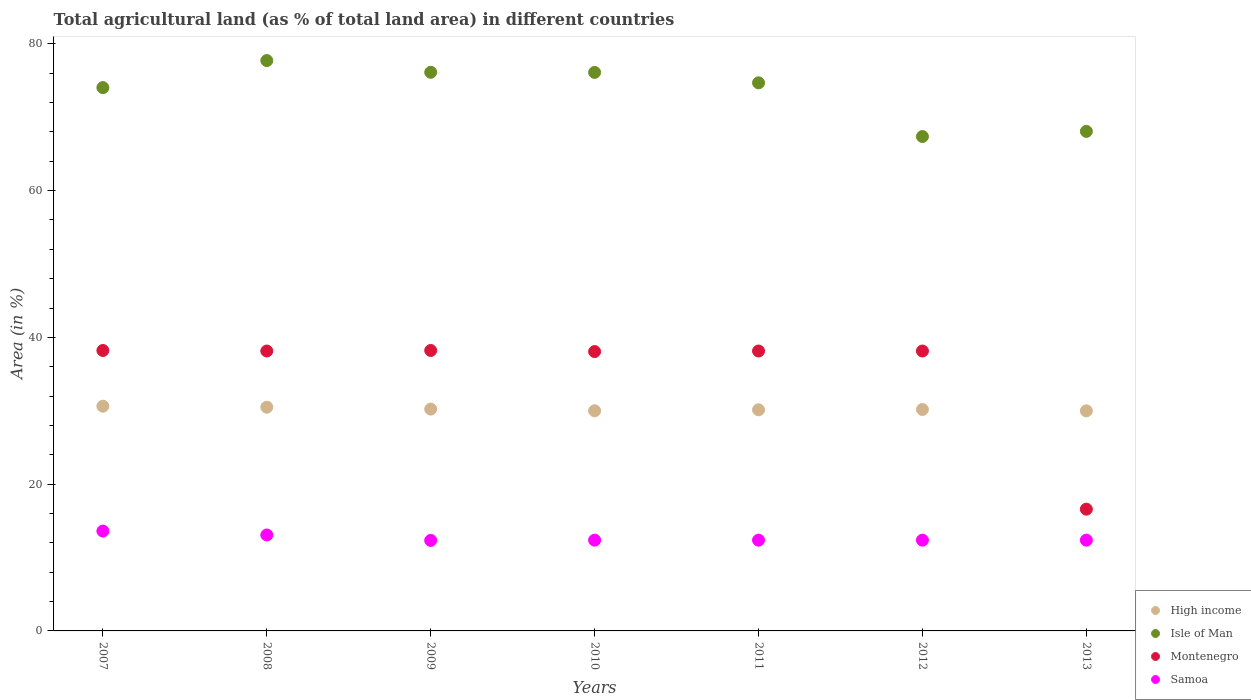Is the number of dotlines equal to the number of legend labels?
Your answer should be very brief. Yes. What is the percentage of agricultural land in Samoa in 2010?
Offer a terse response. 12.37. Across all years, what is the maximum percentage of agricultural land in Isle of Man?
Ensure brevity in your answer.  77.72. Across all years, what is the minimum percentage of agricultural land in Isle of Man?
Offer a terse response. 67.37. In which year was the percentage of agricultural land in Samoa maximum?
Keep it short and to the point. 2007. In which year was the percentage of agricultural land in Isle of Man minimum?
Your response must be concise. 2012. What is the total percentage of agricultural land in Isle of Man in the graph?
Keep it short and to the point. 514.11. What is the difference between the percentage of agricultural land in Isle of Man in 2010 and that in 2012?
Provide a succinct answer. 8.74. What is the difference between the percentage of agricultural land in High income in 2008 and the percentage of agricultural land in Samoa in 2012?
Provide a short and direct response. 18.12. What is the average percentage of agricultural land in Montenegro per year?
Give a very brief answer. 35.07. In the year 2007, what is the difference between the percentage of agricultural land in Isle of Man and percentage of agricultural land in High income?
Give a very brief answer. 43.41. In how many years, is the percentage of agricultural land in Samoa greater than 52 %?
Your answer should be very brief. 0. What is the ratio of the percentage of agricultural land in Samoa in 2008 to that in 2011?
Ensure brevity in your answer.  1.06. Is the difference between the percentage of agricultural land in Isle of Man in 2007 and 2013 greater than the difference between the percentage of agricultural land in High income in 2007 and 2013?
Give a very brief answer. Yes. What is the difference between the highest and the second highest percentage of agricultural land in Montenegro?
Your response must be concise. 0. What is the difference between the highest and the lowest percentage of agricultural land in Samoa?
Ensure brevity in your answer.  1.27. In how many years, is the percentage of agricultural land in Montenegro greater than the average percentage of agricultural land in Montenegro taken over all years?
Ensure brevity in your answer.  6. Is the sum of the percentage of agricultural land in Isle of Man in 2007 and 2012 greater than the maximum percentage of agricultural land in Montenegro across all years?
Your answer should be very brief. Yes. Is it the case that in every year, the sum of the percentage of agricultural land in Isle of Man and percentage of agricultural land in High income  is greater than the sum of percentage of agricultural land in Montenegro and percentage of agricultural land in Samoa?
Give a very brief answer. Yes. Is the percentage of agricultural land in Samoa strictly greater than the percentage of agricultural land in High income over the years?
Offer a very short reply. No. Are the values on the major ticks of Y-axis written in scientific E-notation?
Keep it short and to the point. No. Does the graph contain any zero values?
Offer a terse response. No. Does the graph contain grids?
Your response must be concise. No. Where does the legend appear in the graph?
Your answer should be very brief. Bottom right. What is the title of the graph?
Provide a succinct answer. Total agricultural land (as % of total land area) in different countries. Does "Portugal" appear as one of the legend labels in the graph?
Your answer should be very brief. No. What is the label or title of the Y-axis?
Your answer should be compact. Area (in %). What is the Area (in %) in High income in 2007?
Your response must be concise. 30.62. What is the Area (in %) of Isle of Man in 2007?
Make the answer very short. 74.04. What is the Area (in %) in Montenegro in 2007?
Give a very brief answer. 38.22. What is the Area (in %) of Samoa in 2007?
Your answer should be very brief. 13.6. What is the Area (in %) in High income in 2008?
Provide a short and direct response. 30.49. What is the Area (in %) of Isle of Man in 2008?
Make the answer very short. 77.72. What is the Area (in %) of Montenegro in 2008?
Your answer should be very brief. 38.14. What is the Area (in %) of Samoa in 2008?
Ensure brevity in your answer.  13.07. What is the Area (in %) in High income in 2009?
Make the answer very short. 30.23. What is the Area (in %) in Isle of Man in 2009?
Your response must be concise. 76.12. What is the Area (in %) of Montenegro in 2009?
Keep it short and to the point. 38.22. What is the Area (in %) in Samoa in 2009?
Keep it short and to the point. 12.33. What is the Area (in %) of High income in 2010?
Give a very brief answer. 30. What is the Area (in %) in Isle of Man in 2010?
Offer a terse response. 76.11. What is the Area (in %) of Montenegro in 2010?
Give a very brief answer. 38.07. What is the Area (in %) of Samoa in 2010?
Provide a succinct answer. 12.37. What is the Area (in %) in High income in 2011?
Provide a short and direct response. 30.13. What is the Area (in %) of Isle of Man in 2011?
Make the answer very short. 74.68. What is the Area (in %) of Montenegro in 2011?
Your response must be concise. 38.14. What is the Area (in %) in Samoa in 2011?
Offer a terse response. 12.37. What is the Area (in %) in High income in 2012?
Give a very brief answer. 30.17. What is the Area (in %) in Isle of Man in 2012?
Make the answer very short. 67.37. What is the Area (in %) of Montenegro in 2012?
Keep it short and to the point. 38.14. What is the Area (in %) of Samoa in 2012?
Provide a short and direct response. 12.37. What is the Area (in %) of High income in 2013?
Make the answer very short. 29.99. What is the Area (in %) in Isle of Man in 2013?
Make the answer very short. 68.07. What is the Area (in %) of Montenegro in 2013?
Keep it short and to the point. 16.59. What is the Area (in %) of Samoa in 2013?
Your response must be concise. 12.37. Across all years, what is the maximum Area (in %) of High income?
Your answer should be very brief. 30.62. Across all years, what is the maximum Area (in %) of Isle of Man?
Ensure brevity in your answer.  77.72. Across all years, what is the maximum Area (in %) in Montenegro?
Ensure brevity in your answer.  38.22. Across all years, what is the maximum Area (in %) in Samoa?
Offer a terse response. 13.6. Across all years, what is the minimum Area (in %) of High income?
Provide a short and direct response. 29.99. Across all years, what is the minimum Area (in %) of Isle of Man?
Offer a very short reply. 67.37. Across all years, what is the minimum Area (in %) in Montenegro?
Keep it short and to the point. 16.59. Across all years, what is the minimum Area (in %) of Samoa?
Offer a terse response. 12.33. What is the total Area (in %) in High income in the graph?
Provide a succinct answer. 211.62. What is the total Area (in %) of Isle of Man in the graph?
Offer a terse response. 514.11. What is the total Area (in %) of Montenegro in the graph?
Keep it short and to the point. 245.51. What is the total Area (in %) in Samoa in the graph?
Make the answer very short. 88.48. What is the difference between the Area (in %) of High income in 2007 and that in 2008?
Offer a terse response. 0.13. What is the difference between the Area (in %) in Isle of Man in 2007 and that in 2008?
Offer a terse response. -3.68. What is the difference between the Area (in %) in Montenegro in 2007 and that in 2008?
Your answer should be very brief. 0.07. What is the difference between the Area (in %) in Samoa in 2007 and that in 2008?
Keep it short and to the point. 0.53. What is the difference between the Area (in %) of High income in 2007 and that in 2009?
Keep it short and to the point. 0.39. What is the difference between the Area (in %) in Isle of Man in 2007 and that in 2009?
Keep it short and to the point. -2.09. What is the difference between the Area (in %) of Samoa in 2007 and that in 2009?
Give a very brief answer. 1.27. What is the difference between the Area (in %) of High income in 2007 and that in 2010?
Your answer should be compact. 0.62. What is the difference between the Area (in %) of Isle of Man in 2007 and that in 2010?
Ensure brevity in your answer.  -2.07. What is the difference between the Area (in %) in Montenegro in 2007 and that in 2010?
Your answer should be compact. 0.15. What is the difference between the Area (in %) in Samoa in 2007 and that in 2010?
Your response must be concise. 1.24. What is the difference between the Area (in %) in High income in 2007 and that in 2011?
Make the answer very short. 0.49. What is the difference between the Area (in %) of Isle of Man in 2007 and that in 2011?
Give a very brief answer. -0.65. What is the difference between the Area (in %) in Montenegro in 2007 and that in 2011?
Offer a very short reply. 0.07. What is the difference between the Area (in %) in Samoa in 2007 and that in 2011?
Make the answer very short. 1.24. What is the difference between the Area (in %) of High income in 2007 and that in 2012?
Keep it short and to the point. 0.45. What is the difference between the Area (in %) in Isle of Man in 2007 and that in 2012?
Offer a very short reply. 6.67. What is the difference between the Area (in %) in Montenegro in 2007 and that in 2012?
Offer a terse response. 0.07. What is the difference between the Area (in %) of Samoa in 2007 and that in 2012?
Make the answer very short. 1.24. What is the difference between the Area (in %) of High income in 2007 and that in 2013?
Provide a succinct answer. 0.63. What is the difference between the Area (in %) of Isle of Man in 2007 and that in 2013?
Your answer should be compact. 5.96. What is the difference between the Area (in %) of Montenegro in 2007 and that in 2013?
Make the answer very short. 21.63. What is the difference between the Area (in %) in Samoa in 2007 and that in 2013?
Your answer should be compact. 1.24. What is the difference between the Area (in %) in High income in 2008 and that in 2009?
Your answer should be compact. 0.26. What is the difference between the Area (in %) of Isle of Man in 2008 and that in 2009?
Your answer should be compact. 1.6. What is the difference between the Area (in %) of Montenegro in 2008 and that in 2009?
Ensure brevity in your answer.  -0.07. What is the difference between the Area (in %) of Samoa in 2008 and that in 2009?
Make the answer very short. 0.74. What is the difference between the Area (in %) in High income in 2008 and that in 2010?
Your answer should be very brief. 0.49. What is the difference between the Area (in %) of Isle of Man in 2008 and that in 2010?
Make the answer very short. 1.61. What is the difference between the Area (in %) in Montenegro in 2008 and that in 2010?
Your answer should be compact. 0.07. What is the difference between the Area (in %) of Samoa in 2008 and that in 2010?
Offer a terse response. 0.71. What is the difference between the Area (in %) in High income in 2008 and that in 2011?
Provide a succinct answer. 0.35. What is the difference between the Area (in %) in Isle of Man in 2008 and that in 2011?
Your answer should be compact. 3.04. What is the difference between the Area (in %) of Samoa in 2008 and that in 2011?
Your response must be concise. 0.71. What is the difference between the Area (in %) of High income in 2008 and that in 2012?
Your answer should be very brief. 0.31. What is the difference between the Area (in %) in Isle of Man in 2008 and that in 2012?
Provide a succinct answer. 10.35. What is the difference between the Area (in %) of Samoa in 2008 and that in 2012?
Your answer should be very brief. 0.71. What is the difference between the Area (in %) of High income in 2008 and that in 2013?
Your answer should be compact. 0.5. What is the difference between the Area (in %) in Isle of Man in 2008 and that in 2013?
Your response must be concise. 9.65. What is the difference between the Area (in %) of Montenegro in 2008 and that in 2013?
Keep it short and to the point. 21.55. What is the difference between the Area (in %) in Samoa in 2008 and that in 2013?
Your response must be concise. 0.71. What is the difference between the Area (in %) in High income in 2009 and that in 2010?
Keep it short and to the point. 0.23. What is the difference between the Area (in %) in Isle of Man in 2009 and that in 2010?
Provide a succinct answer. 0.02. What is the difference between the Area (in %) of Montenegro in 2009 and that in 2010?
Offer a terse response. 0.15. What is the difference between the Area (in %) of Samoa in 2009 and that in 2010?
Offer a terse response. -0.04. What is the difference between the Area (in %) of High income in 2009 and that in 2011?
Offer a very short reply. 0.1. What is the difference between the Area (in %) in Isle of Man in 2009 and that in 2011?
Give a very brief answer. 1.44. What is the difference between the Area (in %) of Montenegro in 2009 and that in 2011?
Your answer should be compact. 0.07. What is the difference between the Area (in %) of Samoa in 2009 and that in 2011?
Provide a succinct answer. -0.04. What is the difference between the Area (in %) of High income in 2009 and that in 2012?
Make the answer very short. 0.06. What is the difference between the Area (in %) of Isle of Man in 2009 and that in 2012?
Your response must be concise. 8.75. What is the difference between the Area (in %) in Montenegro in 2009 and that in 2012?
Make the answer very short. 0.07. What is the difference between the Area (in %) of Samoa in 2009 and that in 2012?
Give a very brief answer. -0.04. What is the difference between the Area (in %) of High income in 2009 and that in 2013?
Your answer should be compact. 0.24. What is the difference between the Area (in %) in Isle of Man in 2009 and that in 2013?
Offer a terse response. 8.05. What is the difference between the Area (in %) of Montenegro in 2009 and that in 2013?
Offer a very short reply. 21.63. What is the difference between the Area (in %) of Samoa in 2009 and that in 2013?
Offer a terse response. -0.04. What is the difference between the Area (in %) of High income in 2010 and that in 2011?
Give a very brief answer. -0.13. What is the difference between the Area (in %) of Isle of Man in 2010 and that in 2011?
Offer a terse response. 1.42. What is the difference between the Area (in %) of Montenegro in 2010 and that in 2011?
Your answer should be compact. -0.07. What is the difference between the Area (in %) in Samoa in 2010 and that in 2011?
Offer a very short reply. 0. What is the difference between the Area (in %) of High income in 2010 and that in 2012?
Offer a terse response. -0.17. What is the difference between the Area (in %) of Isle of Man in 2010 and that in 2012?
Offer a very short reply. 8.74. What is the difference between the Area (in %) in Montenegro in 2010 and that in 2012?
Provide a short and direct response. -0.07. What is the difference between the Area (in %) of High income in 2010 and that in 2013?
Offer a very short reply. 0.01. What is the difference between the Area (in %) in Isle of Man in 2010 and that in 2013?
Your response must be concise. 8.04. What is the difference between the Area (in %) of Montenegro in 2010 and that in 2013?
Ensure brevity in your answer.  21.48. What is the difference between the Area (in %) of Samoa in 2010 and that in 2013?
Your response must be concise. 0. What is the difference between the Area (in %) in High income in 2011 and that in 2012?
Ensure brevity in your answer.  -0.04. What is the difference between the Area (in %) in Isle of Man in 2011 and that in 2012?
Your answer should be compact. 7.32. What is the difference between the Area (in %) of Montenegro in 2011 and that in 2012?
Your answer should be very brief. 0. What is the difference between the Area (in %) of Samoa in 2011 and that in 2012?
Give a very brief answer. 0. What is the difference between the Area (in %) in High income in 2011 and that in 2013?
Ensure brevity in your answer.  0.14. What is the difference between the Area (in %) in Isle of Man in 2011 and that in 2013?
Your response must be concise. 6.61. What is the difference between the Area (in %) in Montenegro in 2011 and that in 2013?
Your answer should be very brief. 21.55. What is the difference between the Area (in %) in Samoa in 2011 and that in 2013?
Make the answer very short. 0. What is the difference between the Area (in %) of High income in 2012 and that in 2013?
Your response must be concise. 0.18. What is the difference between the Area (in %) in Isle of Man in 2012 and that in 2013?
Ensure brevity in your answer.  -0.7. What is the difference between the Area (in %) of Montenegro in 2012 and that in 2013?
Offer a terse response. 21.55. What is the difference between the Area (in %) in Samoa in 2012 and that in 2013?
Make the answer very short. 0. What is the difference between the Area (in %) in High income in 2007 and the Area (in %) in Isle of Man in 2008?
Give a very brief answer. -47.1. What is the difference between the Area (in %) in High income in 2007 and the Area (in %) in Montenegro in 2008?
Provide a short and direct response. -7.52. What is the difference between the Area (in %) in High income in 2007 and the Area (in %) in Samoa in 2008?
Offer a very short reply. 17.55. What is the difference between the Area (in %) of Isle of Man in 2007 and the Area (in %) of Montenegro in 2008?
Make the answer very short. 35.89. What is the difference between the Area (in %) in Isle of Man in 2007 and the Area (in %) in Samoa in 2008?
Offer a very short reply. 60.96. What is the difference between the Area (in %) of Montenegro in 2007 and the Area (in %) of Samoa in 2008?
Your answer should be compact. 25.14. What is the difference between the Area (in %) of High income in 2007 and the Area (in %) of Isle of Man in 2009?
Offer a very short reply. -45.5. What is the difference between the Area (in %) of High income in 2007 and the Area (in %) of Montenegro in 2009?
Your answer should be compact. -7.6. What is the difference between the Area (in %) in High income in 2007 and the Area (in %) in Samoa in 2009?
Offer a very short reply. 18.29. What is the difference between the Area (in %) in Isle of Man in 2007 and the Area (in %) in Montenegro in 2009?
Keep it short and to the point. 35.82. What is the difference between the Area (in %) of Isle of Man in 2007 and the Area (in %) of Samoa in 2009?
Keep it short and to the point. 61.7. What is the difference between the Area (in %) of Montenegro in 2007 and the Area (in %) of Samoa in 2009?
Your answer should be very brief. 25.88. What is the difference between the Area (in %) of High income in 2007 and the Area (in %) of Isle of Man in 2010?
Provide a succinct answer. -45.48. What is the difference between the Area (in %) of High income in 2007 and the Area (in %) of Montenegro in 2010?
Your answer should be very brief. -7.45. What is the difference between the Area (in %) of High income in 2007 and the Area (in %) of Samoa in 2010?
Provide a short and direct response. 18.25. What is the difference between the Area (in %) of Isle of Man in 2007 and the Area (in %) of Montenegro in 2010?
Offer a very short reply. 35.97. What is the difference between the Area (in %) in Isle of Man in 2007 and the Area (in %) in Samoa in 2010?
Ensure brevity in your answer.  61.67. What is the difference between the Area (in %) of Montenegro in 2007 and the Area (in %) of Samoa in 2010?
Your answer should be very brief. 25.85. What is the difference between the Area (in %) of High income in 2007 and the Area (in %) of Isle of Man in 2011?
Your response must be concise. -44.06. What is the difference between the Area (in %) of High income in 2007 and the Area (in %) of Montenegro in 2011?
Offer a very short reply. -7.52. What is the difference between the Area (in %) in High income in 2007 and the Area (in %) in Samoa in 2011?
Offer a very short reply. 18.25. What is the difference between the Area (in %) of Isle of Man in 2007 and the Area (in %) of Montenegro in 2011?
Your response must be concise. 35.89. What is the difference between the Area (in %) of Isle of Man in 2007 and the Area (in %) of Samoa in 2011?
Your answer should be very brief. 61.67. What is the difference between the Area (in %) in Montenegro in 2007 and the Area (in %) in Samoa in 2011?
Give a very brief answer. 25.85. What is the difference between the Area (in %) of High income in 2007 and the Area (in %) of Isle of Man in 2012?
Provide a short and direct response. -36.75. What is the difference between the Area (in %) of High income in 2007 and the Area (in %) of Montenegro in 2012?
Provide a short and direct response. -7.52. What is the difference between the Area (in %) in High income in 2007 and the Area (in %) in Samoa in 2012?
Provide a short and direct response. 18.25. What is the difference between the Area (in %) in Isle of Man in 2007 and the Area (in %) in Montenegro in 2012?
Your answer should be very brief. 35.89. What is the difference between the Area (in %) of Isle of Man in 2007 and the Area (in %) of Samoa in 2012?
Give a very brief answer. 61.67. What is the difference between the Area (in %) of Montenegro in 2007 and the Area (in %) of Samoa in 2012?
Your answer should be very brief. 25.85. What is the difference between the Area (in %) in High income in 2007 and the Area (in %) in Isle of Man in 2013?
Provide a short and direct response. -37.45. What is the difference between the Area (in %) in High income in 2007 and the Area (in %) in Montenegro in 2013?
Ensure brevity in your answer.  14.03. What is the difference between the Area (in %) of High income in 2007 and the Area (in %) of Samoa in 2013?
Provide a succinct answer. 18.25. What is the difference between the Area (in %) of Isle of Man in 2007 and the Area (in %) of Montenegro in 2013?
Your answer should be compact. 57.45. What is the difference between the Area (in %) in Isle of Man in 2007 and the Area (in %) in Samoa in 2013?
Offer a terse response. 61.67. What is the difference between the Area (in %) in Montenegro in 2007 and the Area (in %) in Samoa in 2013?
Your answer should be very brief. 25.85. What is the difference between the Area (in %) of High income in 2008 and the Area (in %) of Isle of Man in 2009?
Your answer should be very brief. -45.64. What is the difference between the Area (in %) in High income in 2008 and the Area (in %) in Montenegro in 2009?
Offer a terse response. -7.73. What is the difference between the Area (in %) in High income in 2008 and the Area (in %) in Samoa in 2009?
Offer a very short reply. 18.15. What is the difference between the Area (in %) of Isle of Man in 2008 and the Area (in %) of Montenegro in 2009?
Ensure brevity in your answer.  39.5. What is the difference between the Area (in %) of Isle of Man in 2008 and the Area (in %) of Samoa in 2009?
Make the answer very short. 65.39. What is the difference between the Area (in %) in Montenegro in 2008 and the Area (in %) in Samoa in 2009?
Ensure brevity in your answer.  25.81. What is the difference between the Area (in %) of High income in 2008 and the Area (in %) of Isle of Man in 2010?
Offer a very short reply. -45.62. What is the difference between the Area (in %) of High income in 2008 and the Area (in %) of Montenegro in 2010?
Keep it short and to the point. -7.58. What is the difference between the Area (in %) in High income in 2008 and the Area (in %) in Samoa in 2010?
Offer a terse response. 18.12. What is the difference between the Area (in %) of Isle of Man in 2008 and the Area (in %) of Montenegro in 2010?
Your answer should be compact. 39.65. What is the difference between the Area (in %) of Isle of Man in 2008 and the Area (in %) of Samoa in 2010?
Your answer should be very brief. 65.35. What is the difference between the Area (in %) in Montenegro in 2008 and the Area (in %) in Samoa in 2010?
Ensure brevity in your answer.  25.77. What is the difference between the Area (in %) in High income in 2008 and the Area (in %) in Isle of Man in 2011?
Provide a succinct answer. -44.2. What is the difference between the Area (in %) in High income in 2008 and the Area (in %) in Montenegro in 2011?
Keep it short and to the point. -7.66. What is the difference between the Area (in %) in High income in 2008 and the Area (in %) in Samoa in 2011?
Your response must be concise. 18.12. What is the difference between the Area (in %) of Isle of Man in 2008 and the Area (in %) of Montenegro in 2011?
Your answer should be very brief. 39.58. What is the difference between the Area (in %) of Isle of Man in 2008 and the Area (in %) of Samoa in 2011?
Offer a very short reply. 65.35. What is the difference between the Area (in %) of Montenegro in 2008 and the Area (in %) of Samoa in 2011?
Make the answer very short. 25.77. What is the difference between the Area (in %) in High income in 2008 and the Area (in %) in Isle of Man in 2012?
Give a very brief answer. -36.88. What is the difference between the Area (in %) in High income in 2008 and the Area (in %) in Montenegro in 2012?
Provide a short and direct response. -7.66. What is the difference between the Area (in %) of High income in 2008 and the Area (in %) of Samoa in 2012?
Provide a short and direct response. 18.12. What is the difference between the Area (in %) of Isle of Man in 2008 and the Area (in %) of Montenegro in 2012?
Offer a very short reply. 39.58. What is the difference between the Area (in %) of Isle of Man in 2008 and the Area (in %) of Samoa in 2012?
Offer a terse response. 65.35. What is the difference between the Area (in %) in Montenegro in 2008 and the Area (in %) in Samoa in 2012?
Ensure brevity in your answer.  25.77. What is the difference between the Area (in %) in High income in 2008 and the Area (in %) in Isle of Man in 2013?
Your answer should be compact. -37.58. What is the difference between the Area (in %) of High income in 2008 and the Area (in %) of Montenegro in 2013?
Make the answer very short. 13.9. What is the difference between the Area (in %) of High income in 2008 and the Area (in %) of Samoa in 2013?
Your answer should be very brief. 18.12. What is the difference between the Area (in %) of Isle of Man in 2008 and the Area (in %) of Montenegro in 2013?
Ensure brevity in your answer.  61.13. What is the difference between the Area (in %) in Isle of Man in 2008 and the Area (in %) in Samoa in 2013?
Ensure brevity in your answer.  65.35. What is the difference between the Area (in %) in Montenegro in 2008 and the Area (in %) in Samoa in 2013?
Keep it short and to the point. 25.77. What is the difference between the Area (in %) in High income in 2009 and the Area (in %) in Isle of Man in 2010?
Give a very brief answer. -45.88. What is the difference between the Area (in %) of High income in 2009 and the Area (in %) of Montenegro in 2010?
Keep it short and to the point. -7.84. What is the difference between the Area (in %) of High income in 2009 and the Area (in %) of Samoa in 2010?
Offer a terse response. 17.86. What is the difference between the Area (in %) in Isle of Man in 2009 and the Area (in %) in Montenegro in 2010?
Your answer should be very brief. 38.06. What is the difference between the Area (in %) in Isle of Man in 2009 and the Area (in %) in Samoa in 2010?
Provide a short and direct response. 63.76. What is the difference between the Area (in %) in Montenegro in 2009 and the Area (in %) in Samoa in 2010?
Ensure brevity in your answer.  25.85. What is the difference between the Area (in %) of High income in 2009 and the Area (in %) of Isle of Man in 2011?
Provide a short and direct response. -44.46. What is the difference between the Area (in %) in High income in 2009 and the Area (in %) in Montenegro in 2011?
Provide a succinct answer. -7.91. What is the difference between the Area (in %) in High income in 2009 and the Area (in %) in Samoa in 2011?
Your answer should be very brief. 17.86. What is the difference between the Area (in %) in Isle of Man in 2009 and the Area (in %) in Montenegro in 2011?
Make the answer very short. 37.98. What is the difference between the Area (in %) of Isle of Man in 2009 and the Area (in %) of Samoa in 2011?
Your response must be concise. 63.76. What is the difference between the Area (in %) in Montenegro in 2009 and the Area (in %) in Samoa in 2011?
Your response must be concise. 25.85. What is the difference between the Area (in %) of High income in 2009 and the Area (in %) of Isle of Man in 2012?
Ensure brevity in your answer.  -37.14. What is the difference between the Area (in %) of High income in 2009 and the Area (in %) of Montenegro in 2012?
Your answer should be very brief. -7.91. What is the difference between the Area (in %) of High income in 2009 and the Area (in %) of Samoa in 2012?
Make the answer very short. 17.86. What is the difference between the Area (in %) in Isle of Man in 2009 and the Area (in %) in Montenegro in 2012?
Provide a succinct answer. 37.98. What is the difference between the Area (in %) of Isle of Man in 2009 and the Area (in %) of Samoa in 2012?
Make the answer very short. 63.76. What is the difference between the Area (in %) in Montenegro in 2009 and the Area (in %) in Samoa in 2012?
Provide a succinct answer. 25.85. What is the difference between the Area (in %) in High income in 2009 and the Area (in %) in Isle of Man in 2013?
Offer a very short reply. -37.84. What is the difference between the Area (in %) in High income in 2009 and the Area (in %) in Montenegro in 2013?
Give a very brief answer. 13.64. What is the difference between the Area (in %) of High income in 2009 and the Area (in %) of Samoa in 2013?
Offer a very short reply. 17.86. What is the difference between the Area (in %) of Isle of Man in 2009 and the Area (in %) of Montenegro in 2013?
Your response must be concise. 59.53. What is the difference between the Area (in %) in Isle of Man in 2009 and the Area (in %) in Samoa in 2013?
Your response must be concise. 63.76. What is the difference between the Area (in %) of Montenegro in 2009 and the Area (in %) of Samoa in 2013?
Offer a very short reply. 25.85. What is the difference between the Area (in %) of High income in 2010 and the Area (in %) of Isle of Man in 2011?
Make the answer very short. -44.69. What is the difference between the Area (in %) in High income in 2010 and the Area (in %) in Montenegro in 2011?
Keep it short and to the point. -8.14. What is the difference between the Area (in %) of High income in 2010 and the Area (in %) of Samoa in 2011?
Your answer should be compact. 17.63. What is the difference between the Area (in %) of Isle of Man in 2010 and the Area (in %) of Montenegro in 2011?
Keep it short and to the point. 37.96. What is the difference between the Area (in %) in Isle of Man in 2010 and the Area (in %) in Samoa in 2011?
Ensure brevity in your answer.  63.74. What is the difference between the Area (in %) in Montenegro in 2010 and the Area (in %) in Samoa in 2011?
Your answer should be very brief. 25.7. What is the difference between the Area (in %) in High income in 2010 and the Area (in %) in Isle of Man in 2012?
Give a very brief answer. -37.37. What is the difference between the Area (in %) in High income in 2010 and the Area (in %) in Montenegro in 2012?
Your answer should be compact. -8.14. What is the difference between the Area (in %) in High income in 2010 and the Area (in %) in Samoa in 2012?
Offer a very short reply. 17.63. What is the difference between the Area (in %) of Isle of Man in 2010 and the Area (in %) of Montenegro in 2012?
Offer a terse response. 37.96. What is the difference between the Area (in %) of Isle of Man in 2010 and the Area (in %) of Samoa in 2012?
Your answer should be very brief. 63.74. What is the difference between the Area (in %) in Montenegro in 2010 and the Area (in %) in Samoa in 2012?
Your answer should be compact. 25.7. What is the difference between the Area (in %) in High income in 2010 and the Area (in %) in Isle of Man in 2013?
Your response must be concise. -38.07. What is the difference between the Area (in %) in High income in 2010 and the Area (in %) in Montenegro in 2013?
Offer a terse response. 13.41. What is the difference between the Area (in %) in High income in 2010 and the Area (in %) in Samoa in 2013?
Your response must be concise. 17.63. What is the difference between the Area (in %) in Isle of Man in 2010 and the Area (in %) in Montenegro in 2013?
Provide a short and direct response. 59.52. What is the difference between the Area (in %) in Isle of Man in 2010 and the Area (in %) in Samoa in 2013?
Give a very brief answer. 63.74. What is the difference between the Area (in %) of Montenegro in 2010 and the Area (in %) of Samoa in 2013?
Provide a succinct answer. 25.7. What is the difference between the Area (in %) of High income in 2011 and the Area (in %) of Isle of Man in 2012?
Keep it short and to the point. -37.24. What is the difference between the Area (in %) of High income in 2011 and the Area (in %) of Montenegro in 2012?
Make the answer very short. -8.01. What is the difference between the Area (in %) of High income in 2011 and the Area (in %) of Samoa in 2012?
Provide a short and direct response. 17.76. What is the difference between the Area (in %) of Isle of Man in 2011 and the Area (in %) of Montenegro in 2012?
Your answer should be compact. 36.54. What is the difference between the Area (in %) of Isle of Man in 2011 and the Area (in %) of Samoa in 2012?
Provide a succinct answer. 62.32. What is the difference between the Area (in %) in Montenegro in 2011 and the Area (in %) in Samoa in 2012?
Give a very brief answer. 25.77. What is the difference between the Area (in %) of High income in 2011 and the Area (in %) of Isle of Man in 2013?
Offer a very short reply. -37.94. What is the difference between the Area (in %) in High income in 2011 and the Area (in %) in Montenegro in 2013?
Your answer should be compact. 13.54. What is the difference between the Area (in %) in High income in 2011 and the Area (in %) in Samoa in 2013?
Provide a succinct answer. 17.76. What is the difference between the Area (in %) of Isle of Man in 2011 and the Area (in %) of Montenegro in 2013?
Offer a very short reply. 58.09. What is the difference between the Area (in %) in Isle of Man in 2011 and the Area (in %) in Samoa in 2013?
Offer a very short reply. 62.32. What is the difference between the Area (in %) in Montenegro in 2011 and the Area (in %) in Samoa in 2013?
Your response must be concise. 25.77. What is the difference between the Area (in %) of High income in 2012 and the Area (in %) of Isle of Man in 2013?
Your answer should be very brief. -37.9. What is the difference between the Area (in %) of High income in 2012 and the Area (in %) of Montenegro in 2013?
Your response must be concise. 13.58. What is the difference between the Area (in %) in High income in 2012 and the Area (in %) in Samoa in 2013?
Ensure brevity in your answer.  17.8. What is the difference between the Area (in %) in Isle of Man in 2012 and the Area (in %) in Montenegro in 2013?
Keep it short and to the point. 50.78. What is the difference between the Area (in %) in Isle of Man in 2012 and the Area (in %) in Samoa in 2013?
Provide a succinct answer. 55. What is the difference between the Area (in %) of Montenegro in 2012 and the Area (in %) of Samoa in 2013?
Offer a very short reply. 25.77. What is the average Area (in %) of High income per year?
Provide a short and direct response. 30.23. What is the average Area (in %) of Isle of Man per year?
Offer a very short reply. 73.44. What is the average Area (in %) of Montenegro per year?
Offer a terse response. 35.07. What is the average Area (in %) in Samoa per year?
Give a very brief answer. 12.64. In the year 2007, what is the difference between the Area (in %) in High income and Area (in %) in Isle of Man?
Your answer should be compact. -43.41. In the year 2007, what is the difference between the Area (in %) in High income and Area (in %) in Montenegro?
Make the answer very short. -7.6. In the year 2007, what is the difference between the Area (in %) in High income and Area (in %) in Samoa?
Keep it short and to the point. 17.02. In the year 2007, what is the difference between the Area (in %) of Isle of Man and Area (in %) of Montenegro?
Provide a short and direct response. 35.82. In the year 2007, what is the difference between the Area (in %) in Isle of Man and Area (in %) in Samoa?
Your response must be concise. 60.43. In the year 2007, what is the difference between the Area (in %) in Montenegro and Area (in %) in Samoa?
Provide a succinct answer. 24.61. In the year 2008, what is the difference between the Area (in %) in High income and Area (in %) in Isle of Man?
Keep it short and to the point. -47.23. In the year 2008, what is the difference between the Area (in %) of High income and Area (in %) of Montenegro?
Give a very brief answer. -7.66. In the year 2008, what is the difference between the Area (in %) in High income and Area (in %) in Samoa?
Give a very brief answer. 17.41. In the year 2008, what is the difference between the Area (in %) in Isle of Man and Area (in %) in Montenegro?
Ensure brevity in your answer.  39.58. In the year 2008, what is the difference between the Area (in %) of Isle of Man and Area (in %) of Samoa?
Offer a terse response. 64.65. In the year 2008, what is the difference between the Area (in %) of Montenegro and Area (in %) of Samoa?
Ensure brevity in your answer.  25.07. In the year 2009, what is the difference between the Area (in %) in High income and Area (in %) in Isle of Man?
Your answer should be compact. -45.89. In the year 2009, what is the difference between the Area (in %) in High income and Area (in %) in Montenegro?
Your answer should be compact. -7.99. In the year 2009, what is the difference between the Area (in %) in High income and Area (in %) in Samoa?
Offer a terse response. 17.9. In the year 2009, what is the difference between the Area (in %) of Isle of Man and Area (in %) of Montenegro?
Keep it short and to the point. 37.91. In the year 2009, what is the difference between the Area (in %) in Isle of Man and Area (in %) in Samoa?
Provide a succinct answer. 63.79. In the year 2009, what is the difference between the Area (in %) in Montenegro and Area (in %) in Samoa?
Keep it short and to the point. 25.88. In the year 2010, what is the difference between the Area (in %) in High income and Area (in %) in Isle of Man?
Give a very brief answer. -46.11. In the year 2010, what is the difference between the Area (in %) in High income and Area (in %) in Montenegro?
Ensure brevity in your answer.  -8.07. In the year 2010, what is the difference between the Area (in %) of High income and Area (in %) of Samoa?
Your answer should be very brief. 17.63. In the year 2010, what is the difference between the Area (in %) of Isle of Man and Area (in %) of Montenegro?
Offer a terse response. 38.04. In the year 2010, what is the difference between the Area (in %) in Isle of Man and Area (in %) in Samoa?
Provide a short and direct response. 63.74. In the year 2010, what is the difference between the Area (in %) of Montenegro and Area (in %) of Samoa?
Provide a succinct answer. 25.7. In the year 2011, what is the difference between the Area (in %) in High income and Area (in %) in Isle of Man?
Offer a terse response. -44.55. In the year 2011, what is the difference between the Area (in %) of High income and Area (in %) of Montenegro?
Your answer should be compact. -8.01. In the year 2011, what is the difference between the Area (in %) in High income and Area (in %) in Samoa?
Your answer should be very brief. 17.76. In the year 2011, what is the difference between the Area (in %) in Isle of Man and Area (in %) in Montenegro?
Give a very brief answer. 36.54. In the year 2011, what is the difference between the Area (in %) of Isle of Man and Area (in %) of Samoa?
Offer a terse response. 62.32. In the year 2011, what is the difference between the Area (in %) of Montenegro and Area (in %) of Samoa?
Offer a terse response. 25.77. In the year 2012, what is the difference between the Area (in %) in High income and Area (in %) in Isle of Man?
Ensure brevity in your answer.  -37.2. In the year 2012, what is the difference between the Area (in %) of High income and Area (in %) of Montenegro?
Offer a very short reply. -7.97. In the year 2012, what is the difference between the Area (in %) in High income and Area (in %) in Samoa?
Your answer should be compact. 17.8. In the year 2012, what is the difference between the Area (in %) of Isle of Man and Area (in %) of Montenegro?
Your response must be concise. 29.23. In the year 2012, what is the difference between the Area (in %) in Isle of Man and Area (in %) in Samoa?
Make the answer very short. 55. In the year 2012, what is the difference between the Area (in %) of Montenegro and Area (in %) of Samoa?
Offer a terse response. 25.77. In the year 2013, what is the difference between the Area (in %) in High income and Area (in %) in Isle of Man?
Your response must be concise. -38.08. In the year 2013, what is the difference between the Area (in %) of High income and Area (in %) of Montenegro?
Offer a terse response. 13.4. In the year 2013, what is the difference between the Area (in %) of High income and Area (in %) of Samoa?
Make the answer very short. 17.62. In the year 2013, what is the difference between the Area (in %) in Isle of Man and Area (in %) in Montenegro?
Your answer should be very brief. 51.48. In the year 2013, what is the difference between the Area (in %) in Isle of Man and Area (in %) in Samoa?
Provide a short and direct response. 55.7. In the year 2013, what is the difference between the Area (in %) in Montenegro and Area (in %) in Samoa?
Offer a very short reply. 4.22. What is the ratio of the Area (in %) in High income in 2007 to that in 2008?
Keep it short and to the point. 1. What is the ratio of the Area (in %) of Isle of Man in 2007 to that in 2008?
Offer a very short reply. 0.95. What is the ratio of the Area (in %) in Montenegro in 2007 to that in 2008?
Provide a succinct answer. 1. What is the ratio of the Area (in %) of Samoa in 2007 to that in 2008?
Offer a very short reply. 1.04. What is the ratio of the Area (in %) in Isle of Man in 2007 to that in 2009?
Give a very brief answer. 0.97. What is the ratio of the Area (in %) in Montenegro in 2007 to that in 2009?
Offer a terse response. 1. What is the ratio of the Area (in %) in Samoa in 2007 to that in 2009?
Offer a terse response. 1.1. What is the ratio of the Area (in %) of High income in 2007 to that in 2010?
Provide a succinct answer. 1.02. What is the ratio of the Area (in %) of Isle of Man in 2007 to that in 2010?
Give a very brief answer. 0.97. What is the ratio of the Area (in %) of Samoa in 2007 to that in 2010?
Keep it short and to the point. 1.1. What is the ratio of the Area (in %) of High income in 2007 to that in 2011?
Give a very brief answer. 1.02. What is the ratio of the Area (in %) of Isle of Man in 2007 to that in 2011?
Provide a succinct answer. 0.99. What is the ratio of the Area (in %) of Montenegro in 2007 to that in 2011?
Your answer should be very brief. 1. What is the ratio of the Area (in %) in High income in 2007 to that in 2012?
Make the answer very short. 1.01. What is the ratio of the Area (in %) in Isle of Man in 2007 to that in 2012?
Give a very brief answer. 1.1. What is the ratio of the Area (in %) in Montenegro in 2007 to that in 2012?
Give a very brief answer. 1. What is the ratio of the Area (in %) of Samoa in 2007 to that in 2012?
Give a very brief answer. 1.1. What is the ratio of the Area (in %) of High income in 2007 to that in 2013?
Keep it short and to the point. 1.02. What is the ratio of the Area (in %) of Isle of Man in 2007 to that in 2013?
Make the answer very short. 1.09. What is the ratio of the Area (in %) of Montenegro in 2007 to that in 2013?
Offer a terse response. 2.3. What is the ratio of the Area (in %) of High income in 2008 to that in 2009?
Offer a terse response. 1.01. What is the ratio of the Area (in %) in Montenegro in 2008 to that in 2009?
Ensure brevity in your answer.  1. What is the ratio of the Area (in %) of Samoa in 2008 to that in 2009?
Make the answer very short. 1.06. What is the ratio of the Area (in %) in High income in 2008 to that in 2010?
Provide a short and direct response. 1.02. What is the ratio of the Area (in %) in Isle of Man in 2008 to that in 2010?
Provide a short and direct response. 1.02. What is the ratio of the Area (in %) of Montenegro in 2008 to that in 2010?
Provide a succinct answer. 1. What is the ratio of the Area (in %) of Samoa in 2008 to that in 2010?
Your response must be concise. 1.06. What is the ratio of the Area (in %) in High income in 2008 to that in 2011?
Your response must be concise. 1.01. What is the ratio of the Area (in %) in Isle of Man in 2008 to that in 2011?
Provide a short and direct response. 1.04. What is the ratio of the Area (in %) of Montenegro in 2008 to that in 2011?
Your response must be concise. 1. What is the ratio of the Area (in %) in Samoa in 2008 to that in 2011?
Keep it short and to the point. 1.06. What is the ratio of the Area (in %) in High income in 2008 to that in 2012?
Provide a succinct answer. 1.01. What is the ratio of the Area (in %) of Isle of Man in 2008 to that in 2012?
Provide a succinct answer. 1.15. What is the ratio of the Area (in %) in Samoa in 2008 to that in 2012?
Offer a very short reply. 1.06. What is the ratio of the Area (in %) in High income in 2008 to that in 2013?
Your answer should be very brief. 1.02. What is the ratio of the Area (in %) of Isle of Man in 2008 to that in 2013?
Keep it short and to the point. 1.14. What is the ratio of the Area (in %) of Montenegro in 2008 to that in 2013?
Offer a terse response. 2.3. What is the ratio of the Area (in %) in Samoa in 2008 to that in 2013?
Give a very brief answer. 1.06. What is the ratio of the Area (in %) of High income in 2009 to that in 2010?
Offer a very short reply. 1.01. What is the ratio of the Area (in %) of Isle of Man in 2009 to that in 2011?
Make the answer very short. 1.02. What is the ratio of the Area (in %) in Montenegro in 2009 to that in 2011?
Offer a terse response. 1. What is the ratio of the Area (in %) in Isle of Man in 2009 to that in 2012?
Your answer should be compact. 1.13. What is the ratio of the Area (in %) of Samoa in 2009 to that in 2012?
Provide a succinct answer. 1. What is the ratio of the Area (in %) of High income in 2009 to that in 2013?
Offer a terse response. 1.01. What is the ratio of the Area (in %) in Isle of Man in 2009 to that in 2013?
Provide a succinct answer. 1.12. What is the ratio of the Area (in %) of Montenegro in 2009 to that in 2013?
Provide a short and direct response. 2.3. What is the ratio of the Area (in %) of Samoa in 2009 to that in 2013?
Give a very brief answer. 1. What is the ratio of the Area (in %) of Montenegro in 2010 to that in 2011?
Keep it short and to the point. 1. What is the ratio of the Area (in %) of Samoa in 2010 to that in 2011?
Your answer should be compact. 1. What is the ratio of the Area (in %) in High income in 2010 to that in 2012?
Your response must be concise. 0.99. What is the ratio of the Area (in %) in Isle of Man in 2010 to that in 2012?
Your response must be concise. 1.13. What is the ratio of the Area (in %) in Montenegro in 2010 to that in 2012?
Offer a very short reply. 1. What is the ratio of the Area (in %) of Samoa in 2010 to that in 2012?
Your answer should be compact. 1. What is the ratio of the Area (in %) in High income in 2010 to that in 2013?
Your answer should be compact. 1. What is the ratio of the Area (in %) in Isle of Man in 2010 to that in 2013?
Keep it short and to the point. 1.12. What is the ratio of the Area (in %) of Montenegro in 2010 to that in 2013?
Provide a short and direct response. 2.29. What is the ratio of the Area (in %) of High income in 2011 to that in 2012?
Offer a very short reply. 1. What is the ratio of the Area (in %) of Isle of Man in 2011 to that in 2012?
Ensure brevity in your answer.  1.11. What is the ratio of the Area (in %) of Montenegro in 2011 to that in 2012?
Keep it short and to the point. 1. What is the ratio of the Area (in %) of Samoa in 2011 to that in 2012?
Your answer should be compact. 1. What is the ratio of the Area (in %) in Isle of Man in 2011 to that in 2013?
Ensure brevity in your answer.  1.1. What is the ratio of the Area (in %) of Montenegro in 2011 to that in 2013?
Ensure brevity in your answer.  2.3. What is the ratio of the Area (in %) in Samoa in 2011 to that in 2013?
Offer a terse response. 1. What is the ratio of the Area (in %) in Montenegro in 2012 to that in 2013?
Your answer should be compact. 2.3. What is the ratio of the Area (in %) of Samoa in 2012 to that in 2013?
Provide a succinct answer. 1. What is the difference between the highest and the second highest Area (in %) in High income?
Ensure brevity in your answer.  0.13. What is the difference between the highest and the second highest Area (in %) in Isle of Man?
Offer a terse response. 1.6. What is the difference between the highest and the second highest Area (in %) in Montenegro?
Your answer should be very brief. 0. What is the difference between the highest and the second highest Area (in %) in Samoa?
Offer a terse response. 0.53. What is the difference between the highest and the lowest Area (in %) of High income?
Your response must be concise. 0.63. What is the difference between the highest and the lowest Area (in %) in Isle of Man?
Offer a very short reply. 10.35. What is the difference between the highest and the lowest Area (in %) in Montenegro?
Give a very brief answer. 21.63. What is the difference between the highest and the lowest Area (in %) of Samoa?
Make the answer very short. 1.27. 